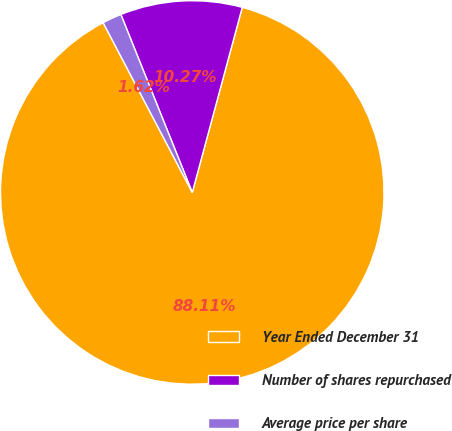Convert chart to OTSL. <chart><loc_0><loc_0><loc_500><loc_500><pie_chart><fcel>Year Ended December 31<fcel>Number of shares repurchased<fcel>Average price per share<nl><fcel>88.1%<fcel>10.27%<fcel>1.62%<nl></chart> 